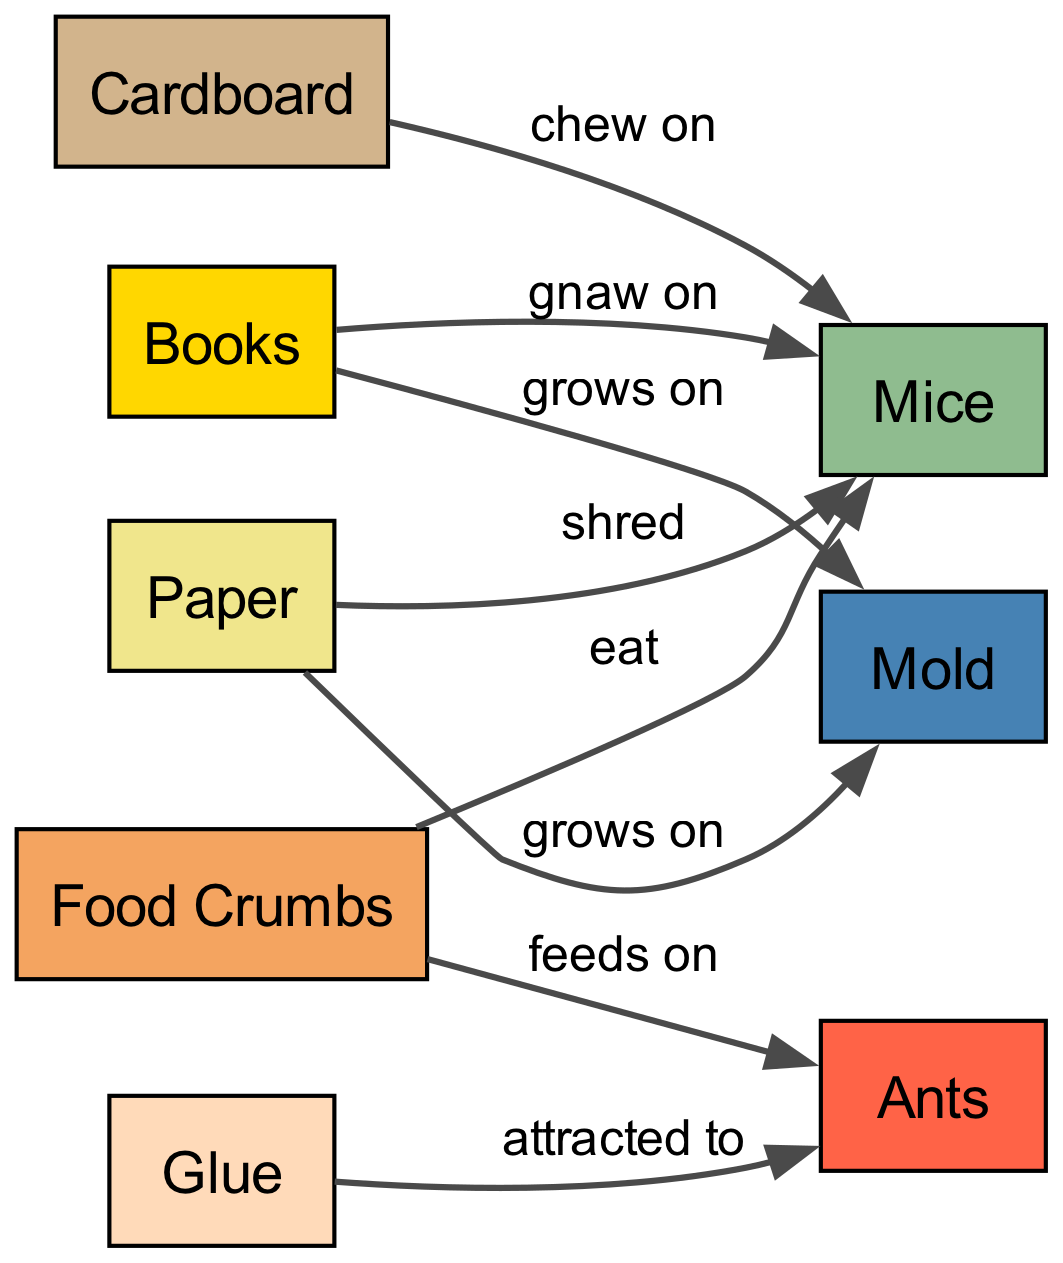What do ants feed on? The diagram directly states that ants feed on food crumbs, as shown by the edge labeled "feeds on" from "FoodCrumbs" to "Ants."
Answer: food crumbs Which organisms do mice gnaw on? According to the diagram, there are three edges showing that mice gnaw on books, and they chew on cardboard and shred paper. By examining these connections, it confirms that mice gnaw on all three shown items.
Answer: books, cardboard, paper What color represents mold in the diagram? The diagram indicates that mold is represented by the color steel blue, as per its assigned color within the visual elements of the graph.
Answer: steel blue How many nodes are in the diagram? By counting the individual elements defined as nodes in the data section, the total comes to eight distinct nodes including books, cardboard, food crumbs, paper, glue, ants, mice, and mold.
Answer: eight What attracts ants according to the diagram? The edge from "Glue" to "Ants," labeled "attracted to," conveys that ants are attracted to glue. This relationship is made clear by examining the specific connection denoted in the diagram.
Answer: glue Which pests grow on books? The diagram shows that mold grows on books, indicated by the edge labeled "grows on" from "Books" to "Mold." This signifies the direct relationship between the two entities.
Answer: mold How many edges connect food crumbs to other elements? Observing the edges starting from "FoodCrumbs," there are two connections: one to ants (feeds on) and one to mice (eat). Thus, there are two edges associated with food crumbs.
Answer: two What materials do mice eat? The diagram provides two specific relationships showing that mice eat food crumbs, and they also gnaw on books, cardboard, and shred paper. Thus, food crumbs are included in their diet.
Answer: food crumbs, books, cardboard, paper 